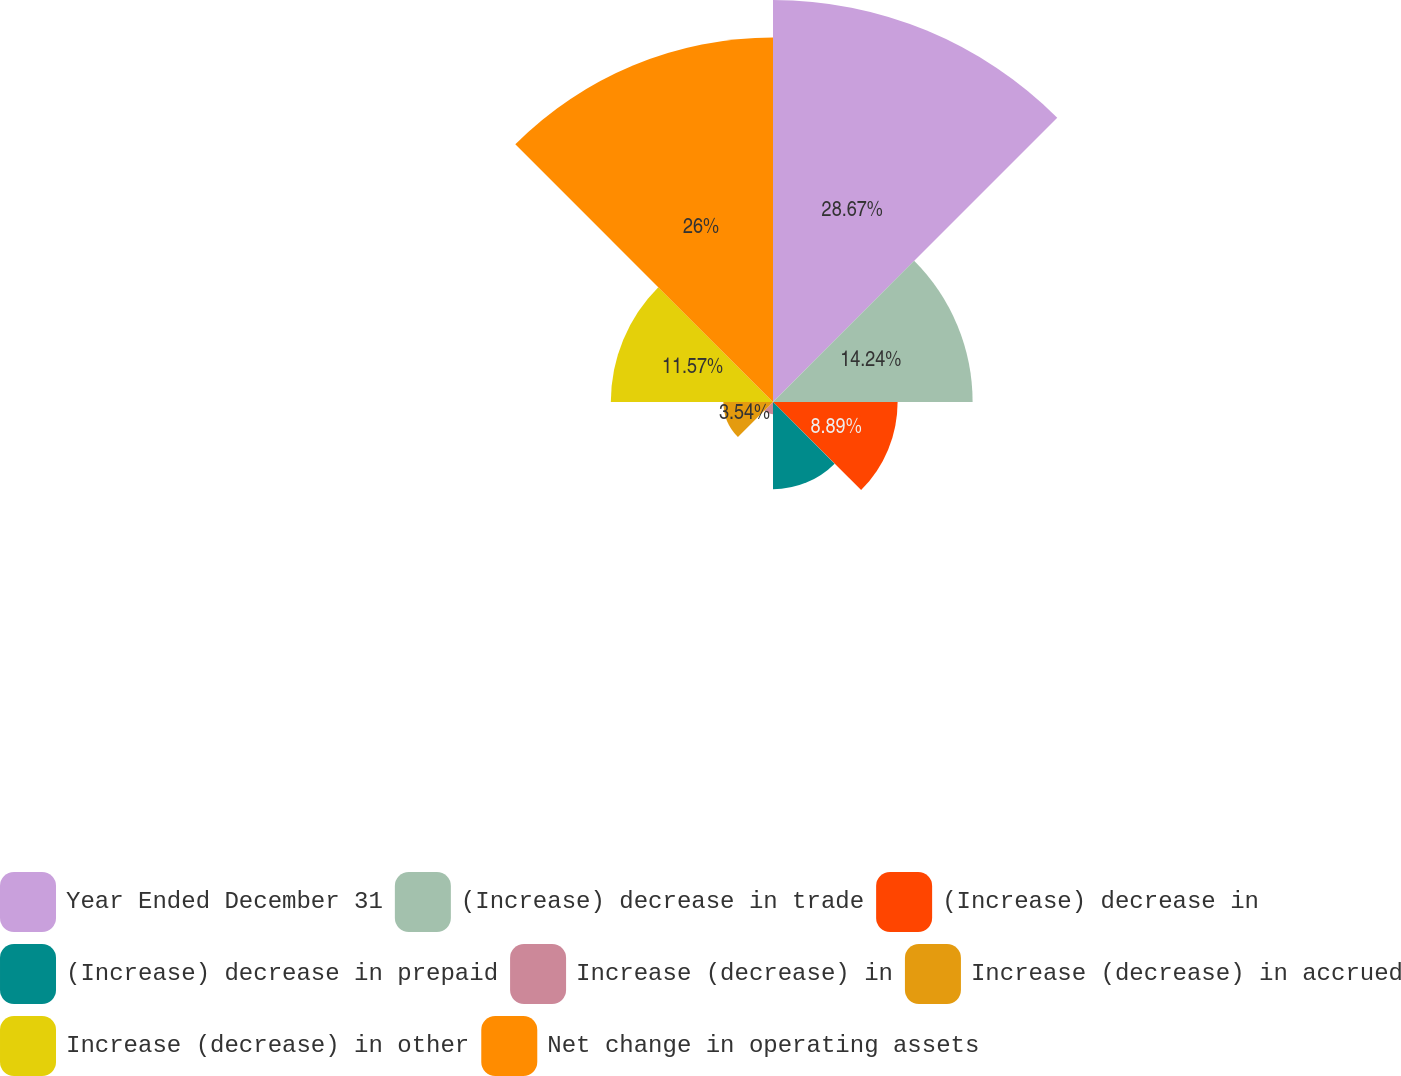Convert chart. <chart><loc_0><loc_0><loc_500><loc_500><pie_chart><fcel>Year Ended December 31<fcel>(Increase) decrease in trade<fcel>(Increase) decrease in<fcel>(Increase) decrease in prepaid<fcel>Increase (decrease) in<fcel>Increase (decrease) in accrued<fcel>Increase (decrease) in other<fcel>Net change in operating assets<nl><fcel>28.68%<fcel>14.24%<fcel>8.89%<fcel>6.22%<fcel>0.87%<fcel>3.54%<fcel>11.57%<fcel>26.0%<nl></chart> 